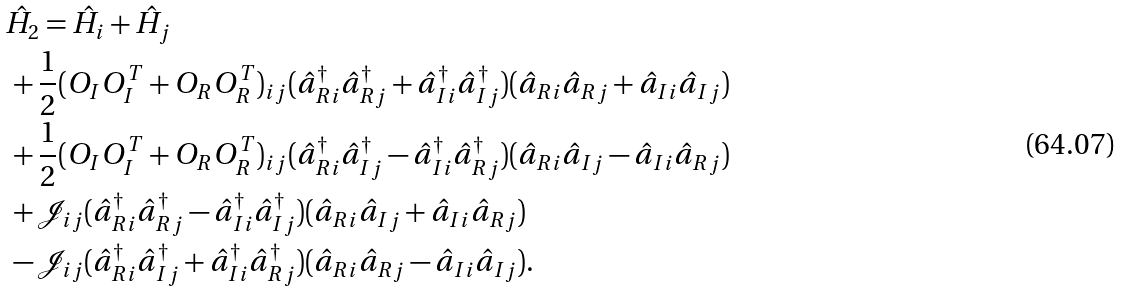<formula> <loc_0><loc_0><loc_500><loc_500>& \hat { H } _ { 2 } = \hat { H } _ { i } + \hat { H } _ { j } \\ & \, + \frac { 1 } { 2 } ( O _ { I } O _ { I } ^ { T } + O _ { R } O _ { R } ^ { T } ) _ { i j } ( \hat { a } ^ { \dag } _ { R i } \hat { a } ^ { \dag } _ { R j } + \hat { a } ^ { \dag } _ { I i } \hat { a } ^ { \dag } _ { I j } ) ( \hat { a } _ { R i } \hat { a } _ { R j } + \hat { a } _ { I i } \hat { a } _ { I j } ) \\ & \, + \frac { 1 } { 2 } ( O _ { I } O _ { I } ^ { T } + O _ { R } O _ { R } ^ { T } ) _ { i j } ( \hat { a } ^ { \dag } _ { R i } \hat { a } ^ { \dag } _ { I j } - \hat { a } ^ { \dag } _ { I i } \hat { a } ^ { \dag } _ { R j } ) ( \hat { a } _ { R i } \hat { a } _ { I j } - \hat { a } _ { I i } \hat { a } _ { R j } ) \\ & \, + \mathcal { J } _ { i j } ( \hat { a } ^ { \dag } _ { R i } \hat { a } ^ { \dag } _ { R j } - \hat { a } ^ { \dag } _ { I i } \hat { a } ^ { \dag } _ { I j } ) ( \hat { a } _ { R i } \hat { a } _ { I j } + \hat { a } _ { I i } \hat { a } _ { R j } ) \\ & \, - \mathcal { J } _ { i j } ( \hat { a } ^ { \dag } _ { R i } \hat { a } ^ { \dag } _ { I j } + \hat { a } ^ { \dag } _ { I i } \hat { a } ^ { \dag } _ { R j } ) ( \hat { a } _ { R i } \hat { a } _ { R j } - \hat { a } _ { I i } \hat { a } _ { I j } ) .</formula> 